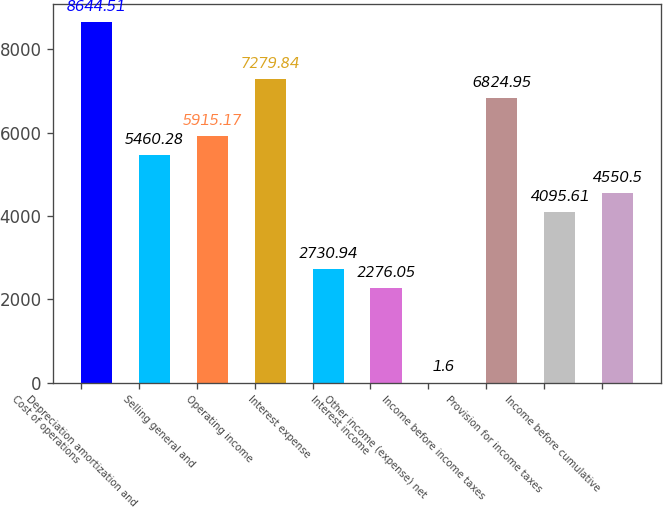<chart> <loc_0><loc_0><loc_500><loc_500><bar_chart><fcel>Cost of operations<fcel>Depreciation amortization and<fcel>Selling general and<fcel>Operating income<fcel>Interest expense<fcel>Interest income<fcel>Other income (expense) net<fcel>Income before income taxes<fcel>Provision for income taxes<fcel>Income before cumulative<nl><fcel>8644.51<fcel>5460.28<fcel>5915.17<fcel>7279.84<fcel>2730.94<fcel>2276.05<fcel>1.6<fcel>6824.95<fcel>4095.61<fcel>4550.5<nl></chart> 